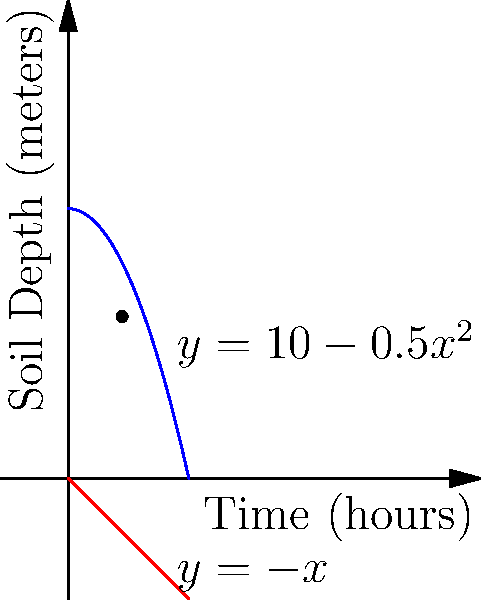As an excavation technology expert, you're analyzing the rate of soil removal during a dig. The depth of soil $y$ (in meters) as a function of time $x$ (in hours) is given by $y=10-0.5x^2$. The excavation team aims to remove soil at a constant rate of 1 meter per hour, represented by the line $y=-x+10$. At what time do these two functions intersect, and what is the instantaneous rate of change of the soil depth at this point of intersection? Let's approach this step-by-step:

1) First, we need to find the point of intersection. This occurs when:

   $10-0.5x^2 = -x+10$

2) Simplifying this equation:

   $0.5x^2 + x = 0$
   $x(0.5x + 1) = 0$

3) Solving this equation:
   
   $x = 0$ or $x = -2$

   Since time can't be negative in this context, $x = 2$ is our solution.

4) Now that we know the time of intersection, we can find the depth at this point:

   $y = 10 - 0.5(2)^2 = 10 - 2 = 8$ meters

5) To find the instantaneous rate of change at this point, we need to find the derivative of the soil depth function and evaluate it at $x = 2$:

   $\frac{dy}{dx} = -x$

6) At $x = 2$:

   $\frac{dy}{dx} = -2$ meters/hour

Therefore, at the point of intersection (2 hours, 8 meters), the instantaneous rate of change of soil depth is -2 meters/hour.
Answer: Time of intersection: 2 hours; Instantaneous rate of change: -2 meters/hour 